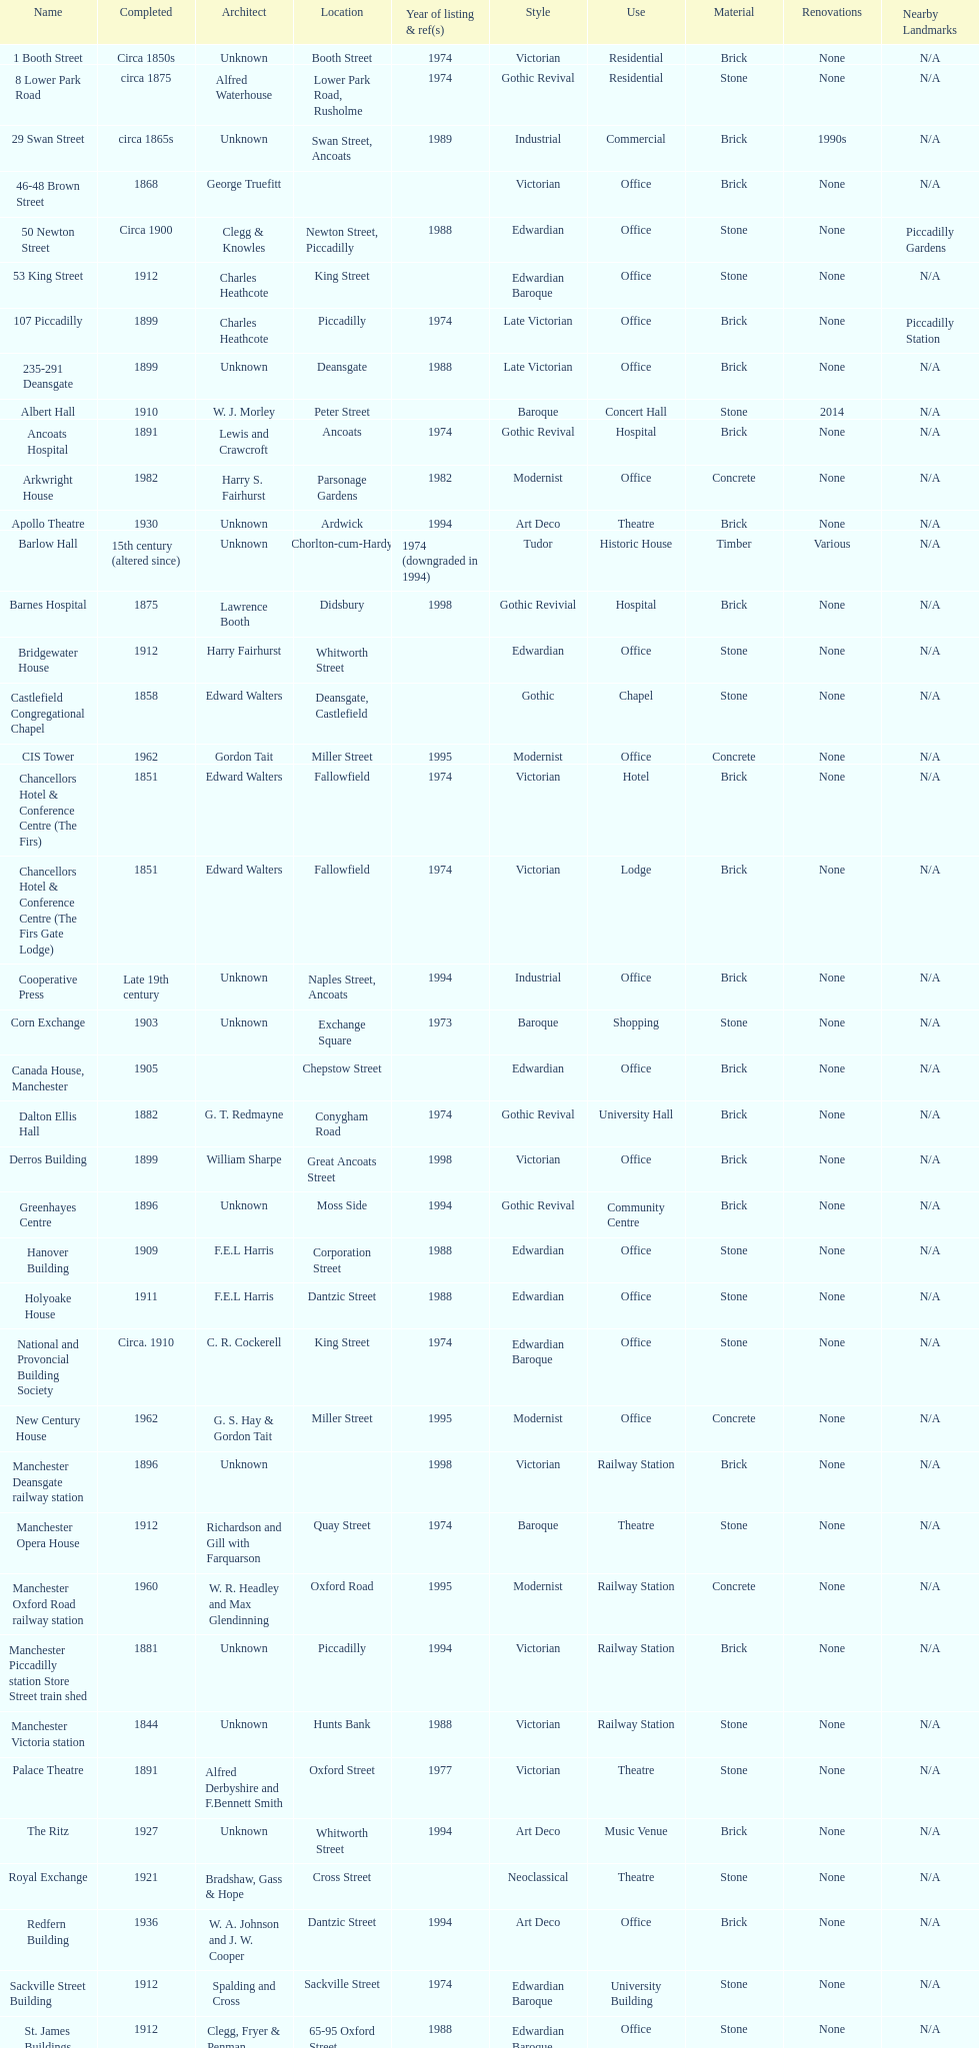How many buildings has the same year of listing as 1974? 15. 